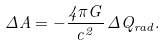Convert formula to latex. <formula><loc_0><loc_0><loc_500><loc_500>\Delta A = - \frac { 4 \pi G } { c ^ { 2 } } \, \Delta Q _ { r a d } .</formula> 